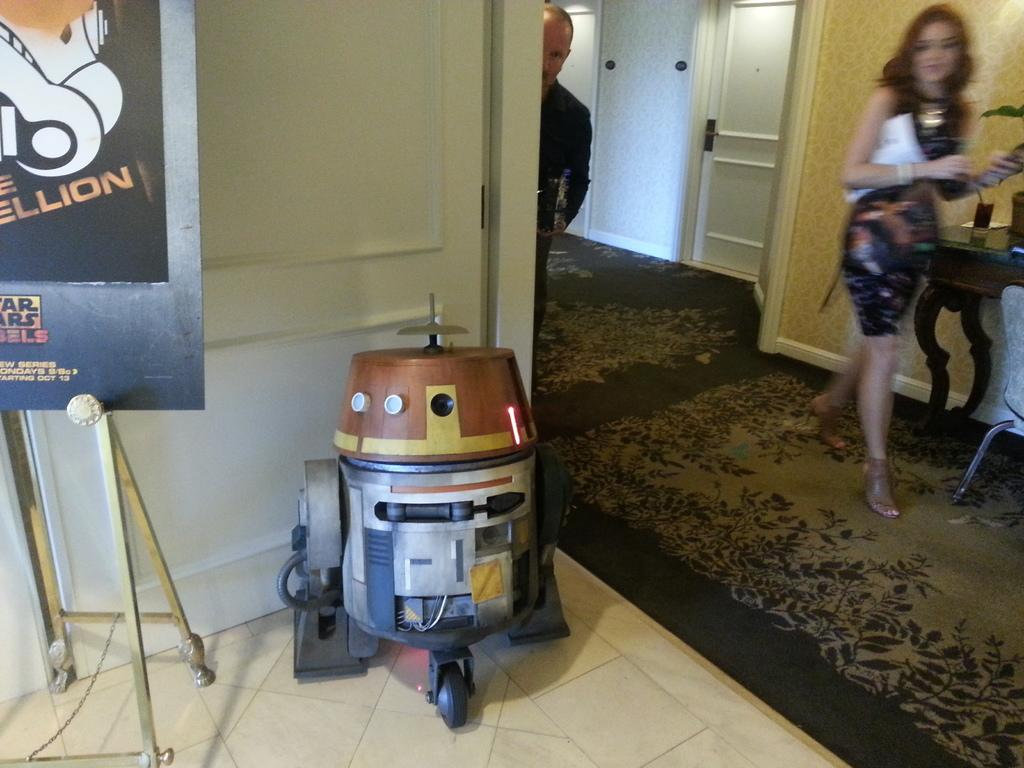<image>
Write a terse but informative summary of the picture. a little robot that is next to a star wars sign 